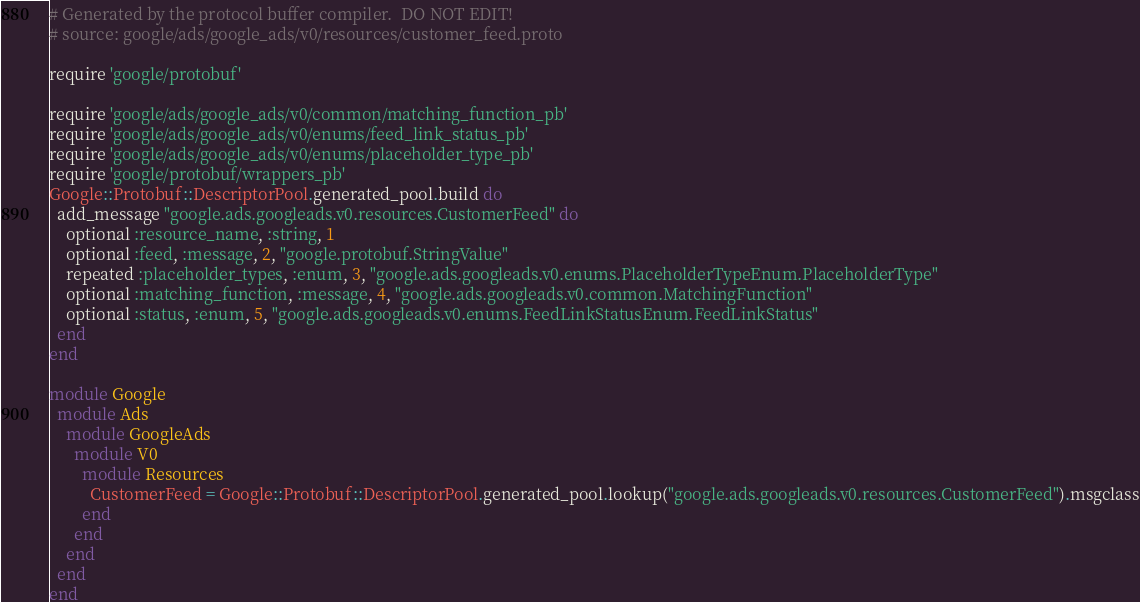<code> <loc_0><loc_0><loc_500><loc_500><_Ruby_># Generated by the protocol buffer compiler.  DO NOT EDIT!
# source: google/ads/google_ads/v0/resources/customer_feed.proto

require 'google/protobuf'

require 'google/ads/google_ads/v0/common/matching_function_pb'
require 'google/ads/google_ads/v0/enums/feed_link_status_pb'
require 'google/ads/google_ads/v0/enums/placeholder_type_pb'
require 'google/protobuf/wrappers_pb'
Google::Protobuf::DescriptorPool.generated_pool.build do
  add_message "google.ads.googleads.v0.resources.CustomerFeed" do
    optional :resource_name, :string, 1
    optional :feed, :message, 2, "google.protobuf.StringValue"
    repeated :placeholder_types, :enum, 3, "google.ads.googleads.v0.enums.PlaceholderTypeEnum.PlaceholderType"
    optional :matching_function, :message, 4, "google.ads.googleads.v0.common.MatchingFunction"
    optional :status, :enum, 5, "google.ads.googleads.v0.enums.FeedLinkStatusEnum.FeedLinkStatus"
  end
end

module Google
  module Ads
    module GoogleAds
      module V0
        module Resources
          CustomerFeed = Google::Protobuf::DescriptorPool.generated_pool.lookup("google.ads.googleads.v0.resources.CustomerFeed").msgclass
        end
      end
    end
  end
end
</code> 